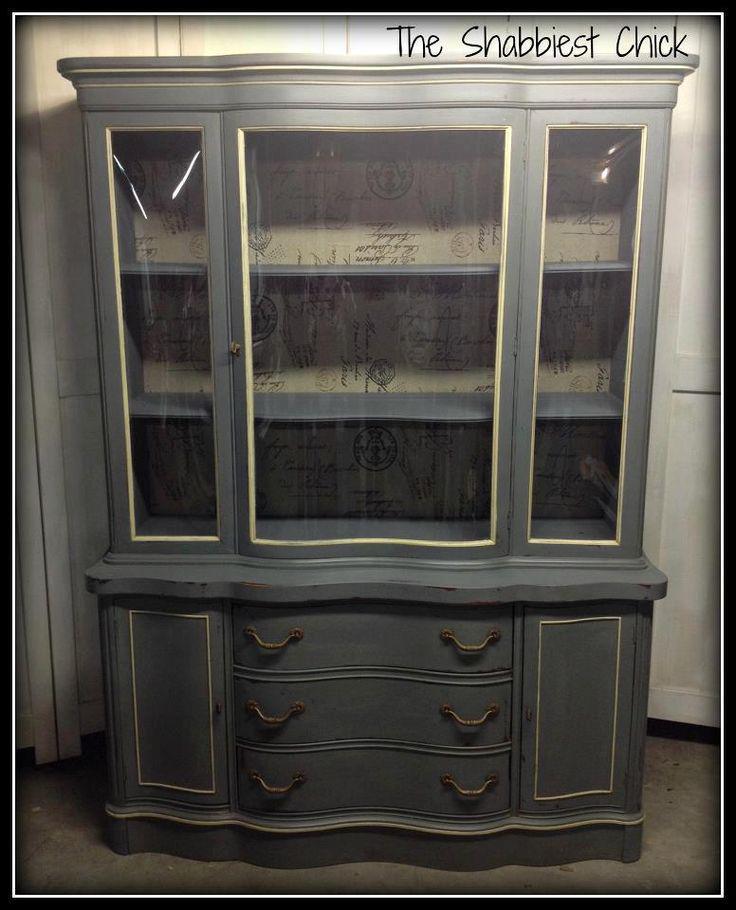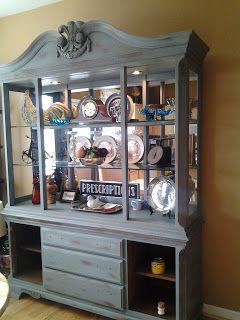The first image is the image on the left, the second image is the image on the right. For the images displayed, is the sentence "The cabinet in the right image has narrow legs and decorative curved top feature." factually correct? Answer yes or no. No. The first image is the image on the left, the second image is the image on the right. Evaluate the accuracy of this statement regarding the images: "An antique wooden piece in one image has a curved top, at least one glass door with an ornate window pane design, and sits on long thin legs.". Is it true? Answer yes or no. No. 